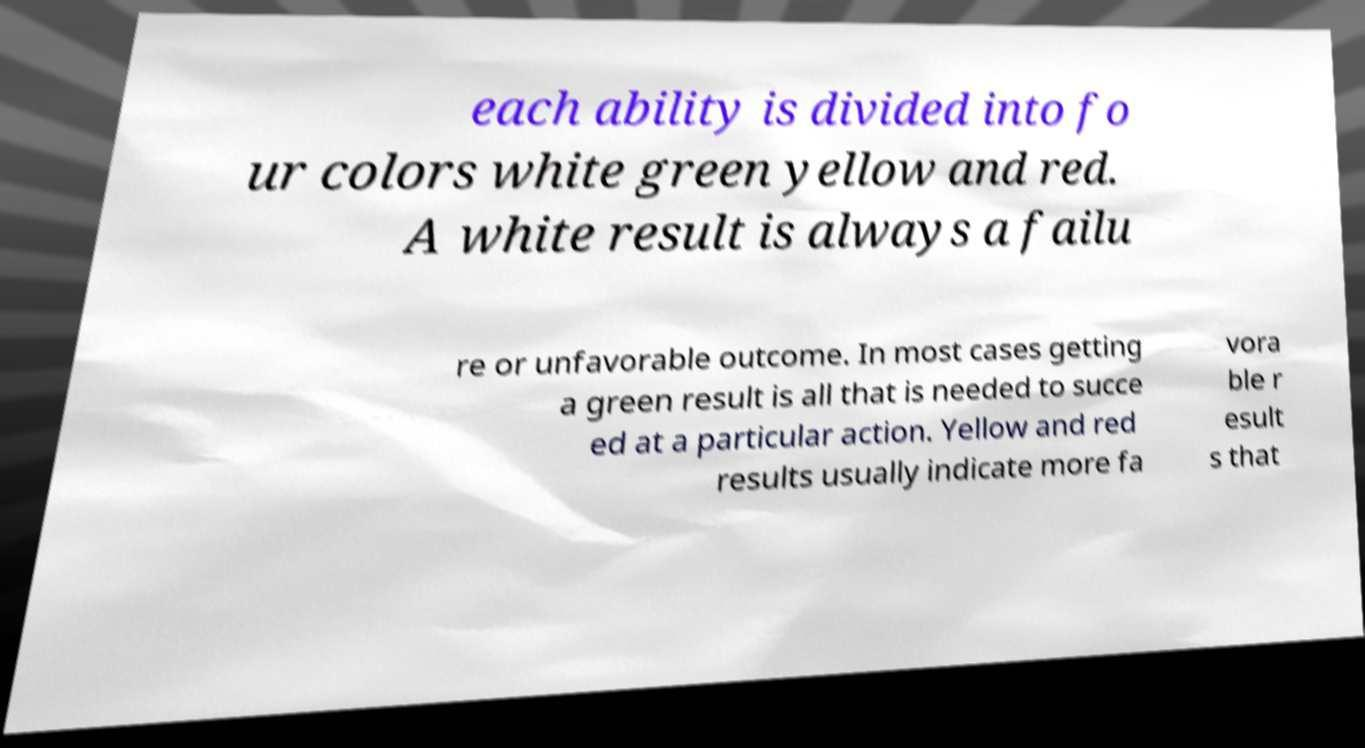Could you extract and type out the text from this image? each ability is divided into fo ur colors white green yellow and red. A white result is always a failu re or unfavorable outcome. In most cases getting a green result is all that is needed to succe ed at a particular action. Yellow and red results usually indicate more fa vora ble r esult s that 